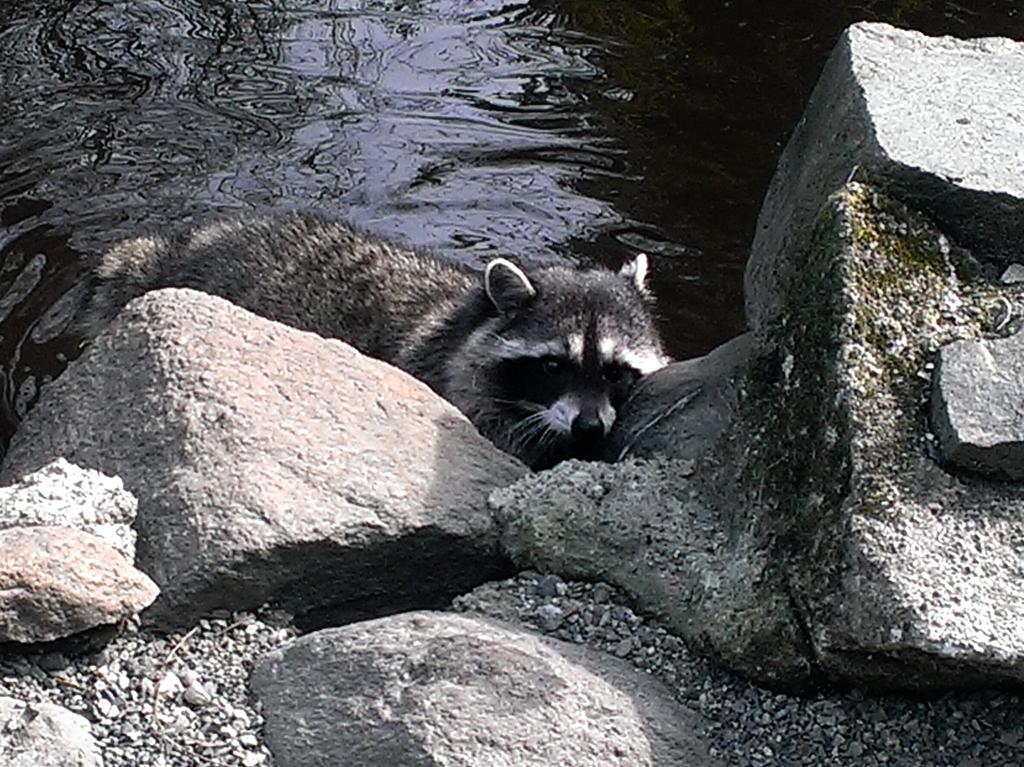Please provide a concise description of this image. In this picture we can see an animal, rocks and water. 